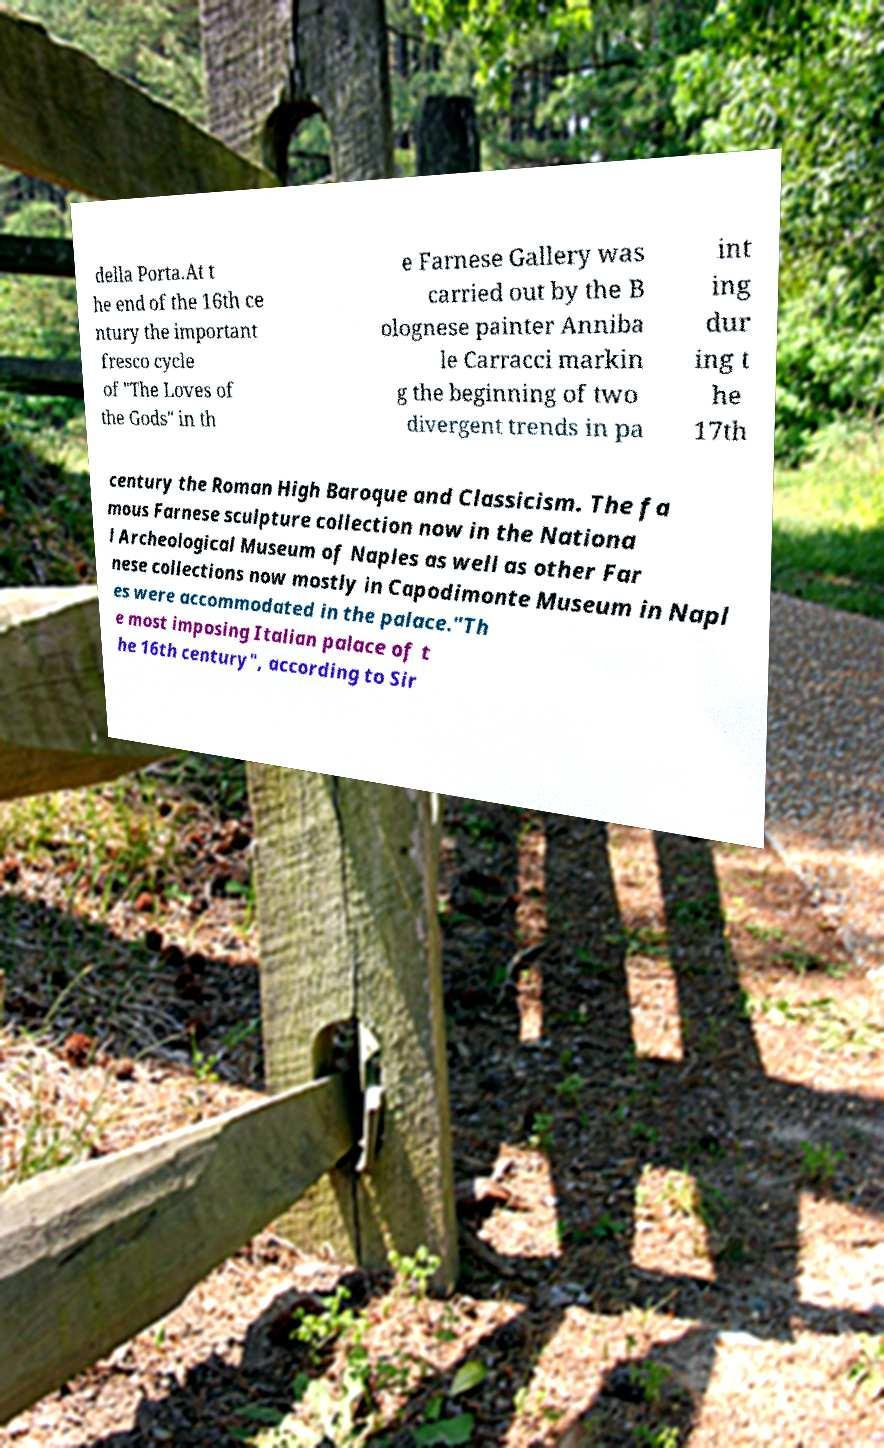Can you accurately transcribe the text from the provided image for me? della Porta.At t he end of the 16th ce ntury the important fresco cycle of "The Loves of the Gods" in th e Farnese Gallery was carried out by the B olognese painter Anniba le Carracci markin g the beginning of two divergent trends in pa int ing dur ing t he 17th century the Roman High Baroque and Classicism. The fa mous Farnese sculpture collection now in the Nationa l Archeological Museum of Naples as well as other Far nese collections now mostly in Capodimonte Museum in Napl es were accommodated in the palace."Th e most imposing Italian palace of t he 16th century", according to Sir 